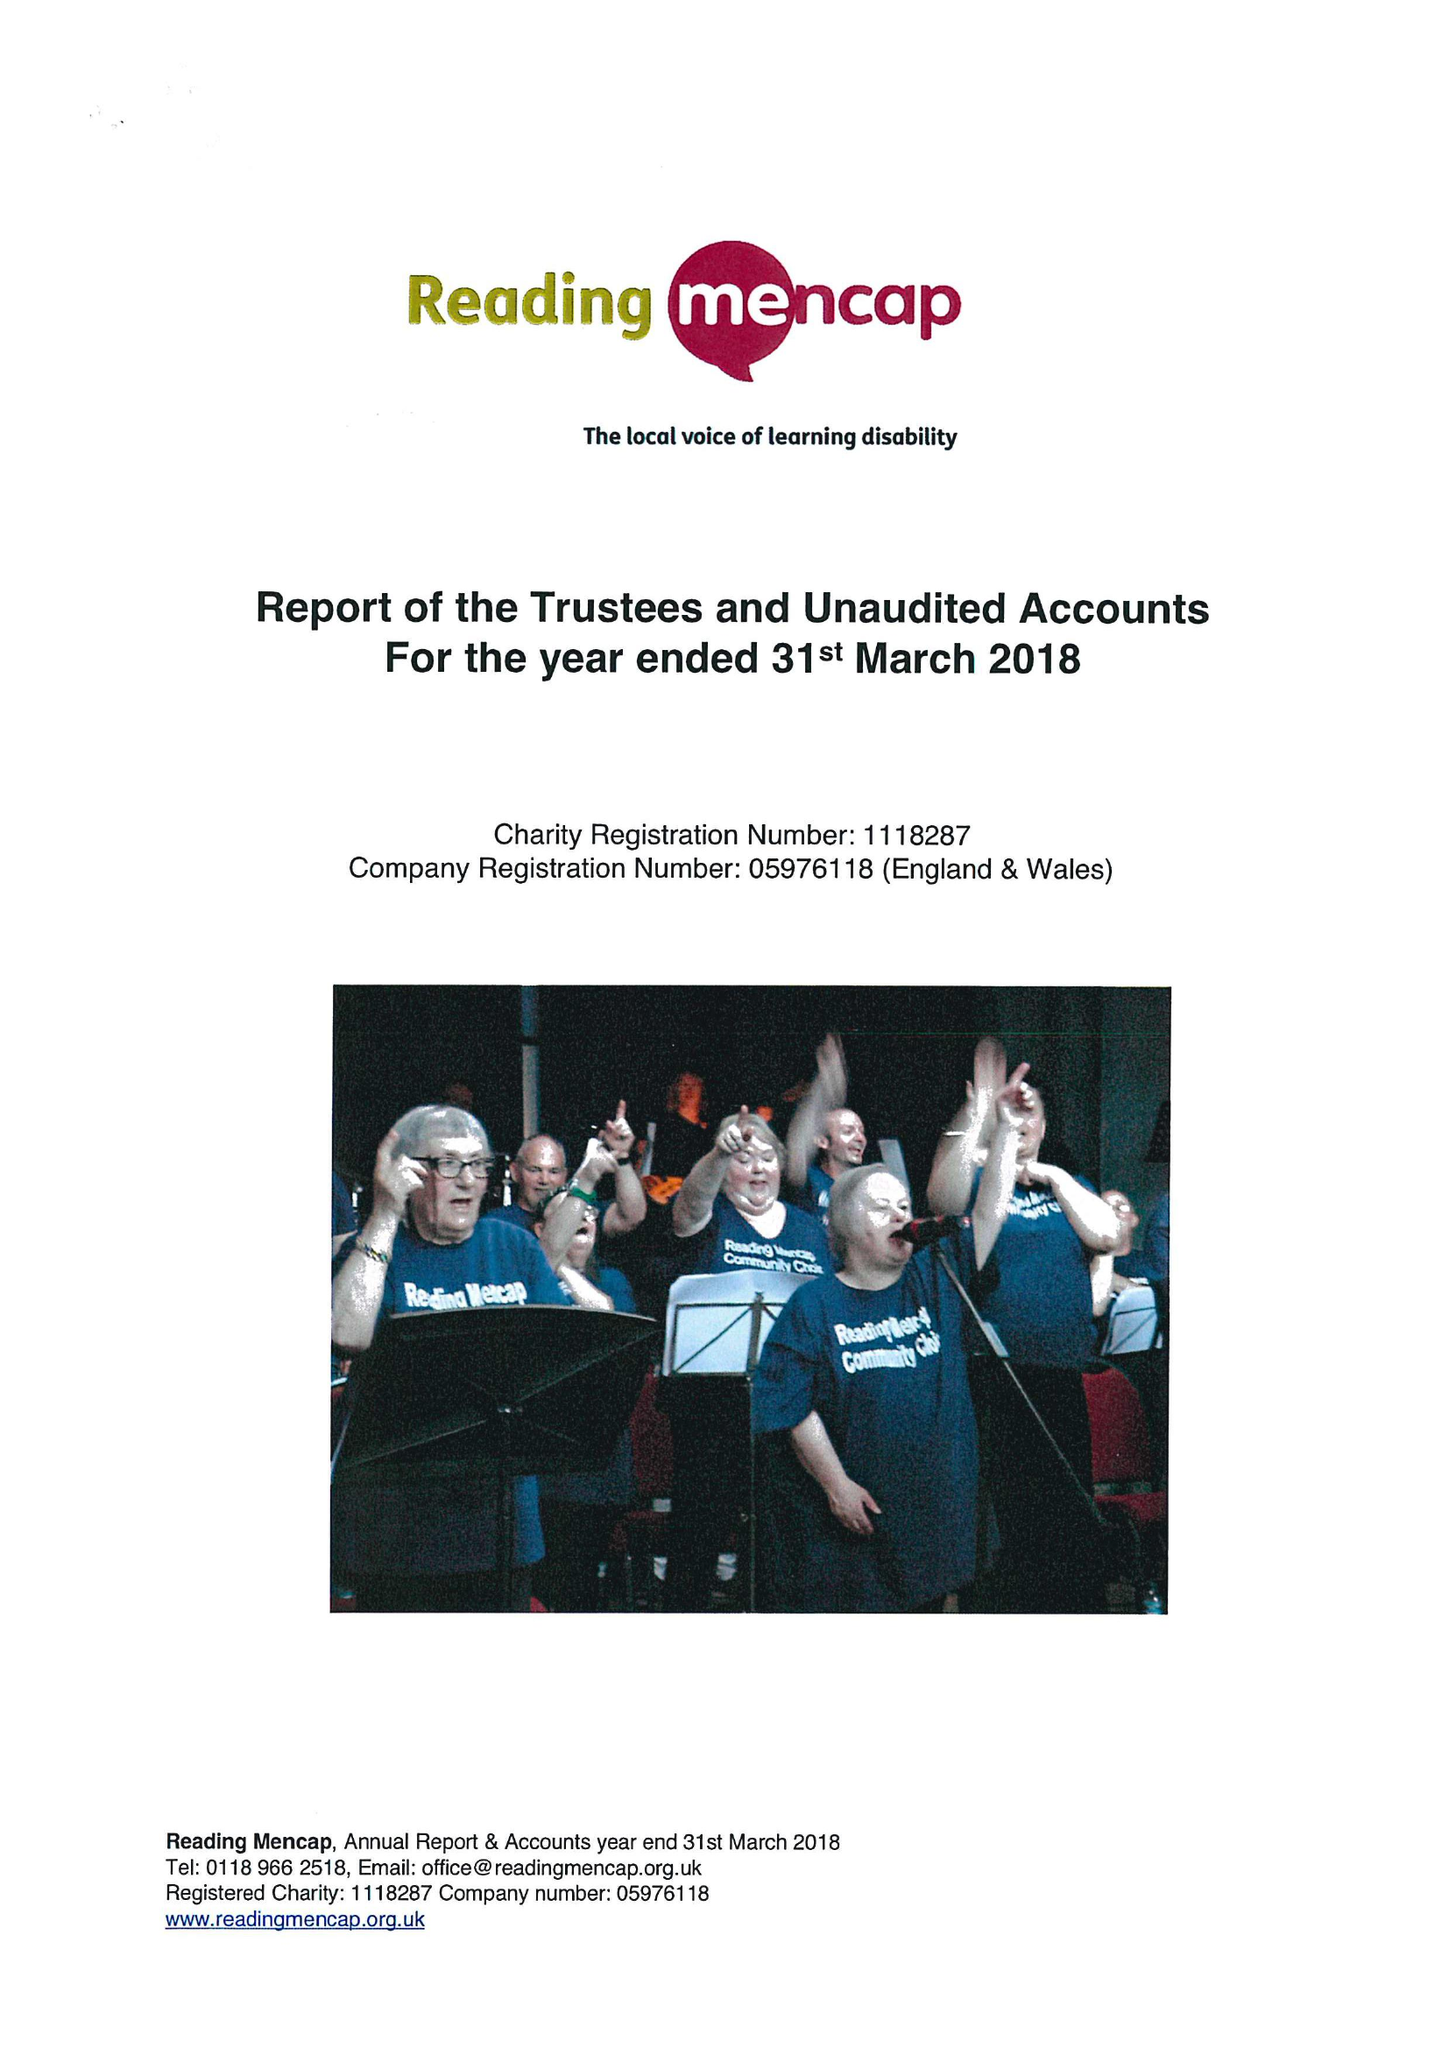What is the value for the report_date?
Answer the question using a single word or phrase. 2018-03-31 